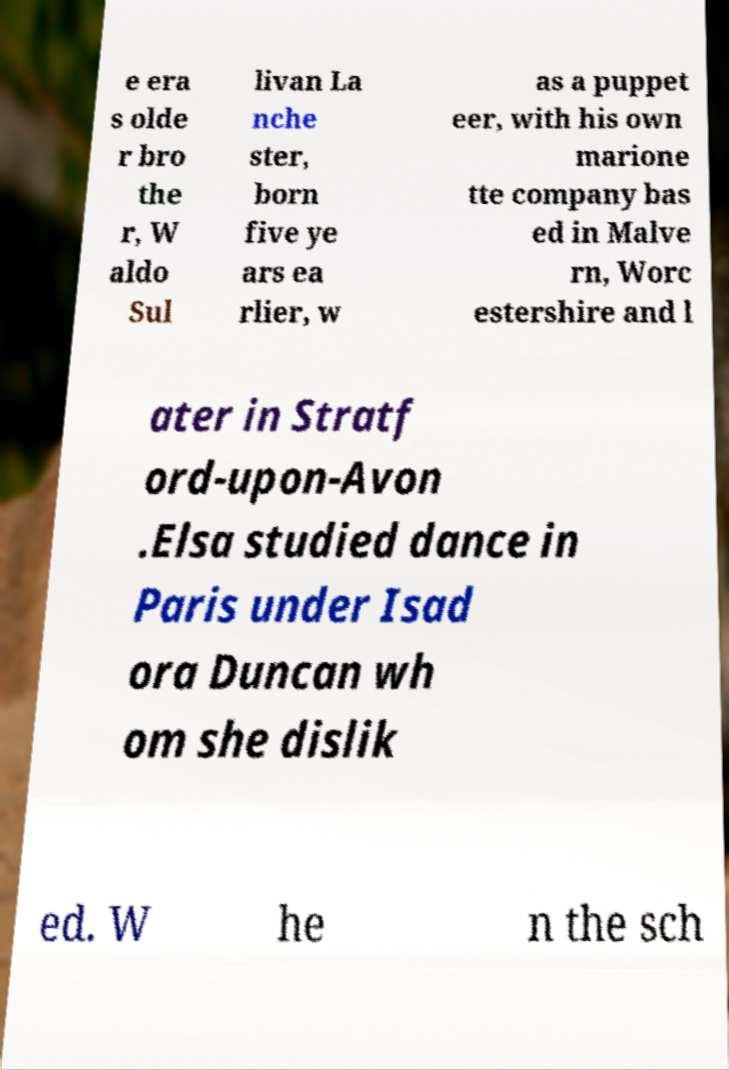Could you extract and type out the text from this image? e era s olde r bro the r, W aldo Sul livan La nche ster, born five ye ars ea rlier, w as a puppet eer, with his own marione tte company bas ed in Malve rn, Worc estershire and l ater in Stratf ord-upon-Avon .Elsa studied dance in Paris under Isad ora Duncan wh om she dislik ed. W he n the sch 